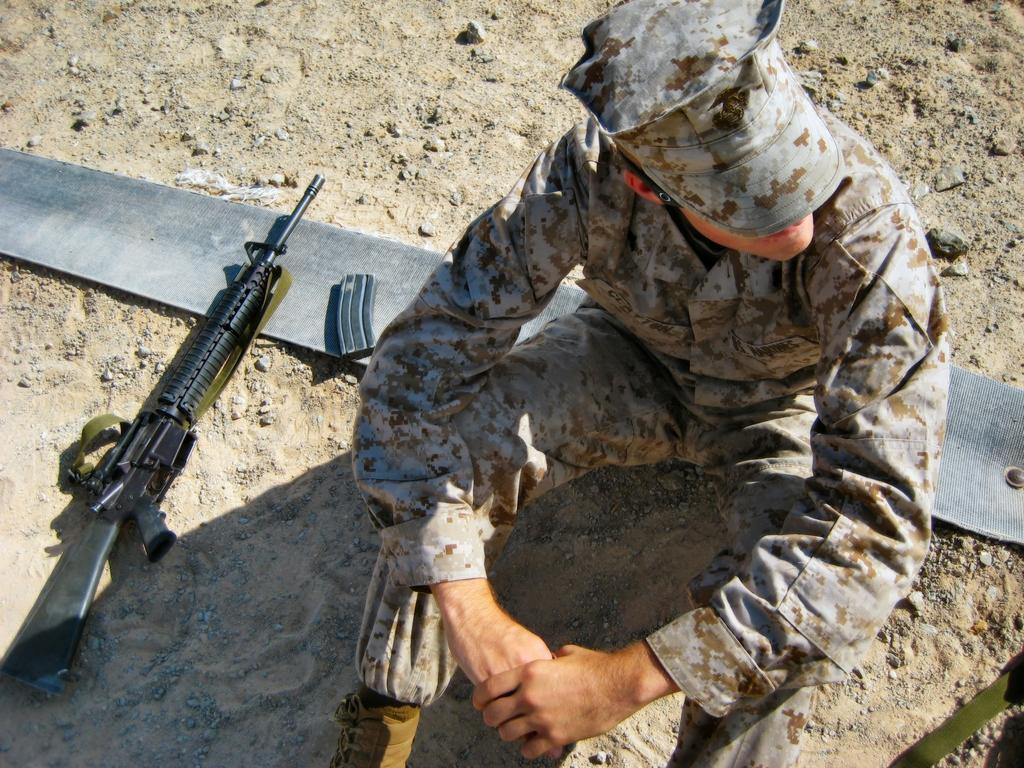Could you give a brief overview of what you see in this image? In this image I can see a person wearing uniform is sitting on the ground, beside him there is a gun and other object. 